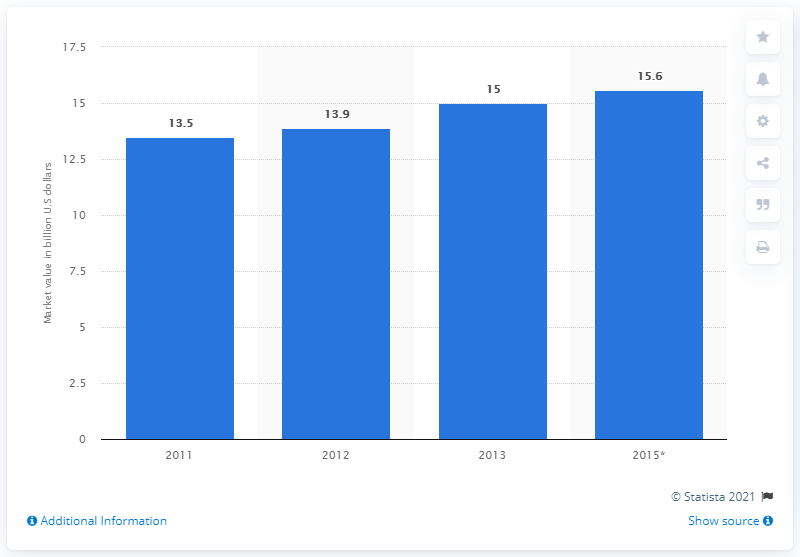Mention a couple of crucial points in this snapshot. The worth of the Russian beauty market in the United States was estimated to be 15 billion US dollars in 2013. 